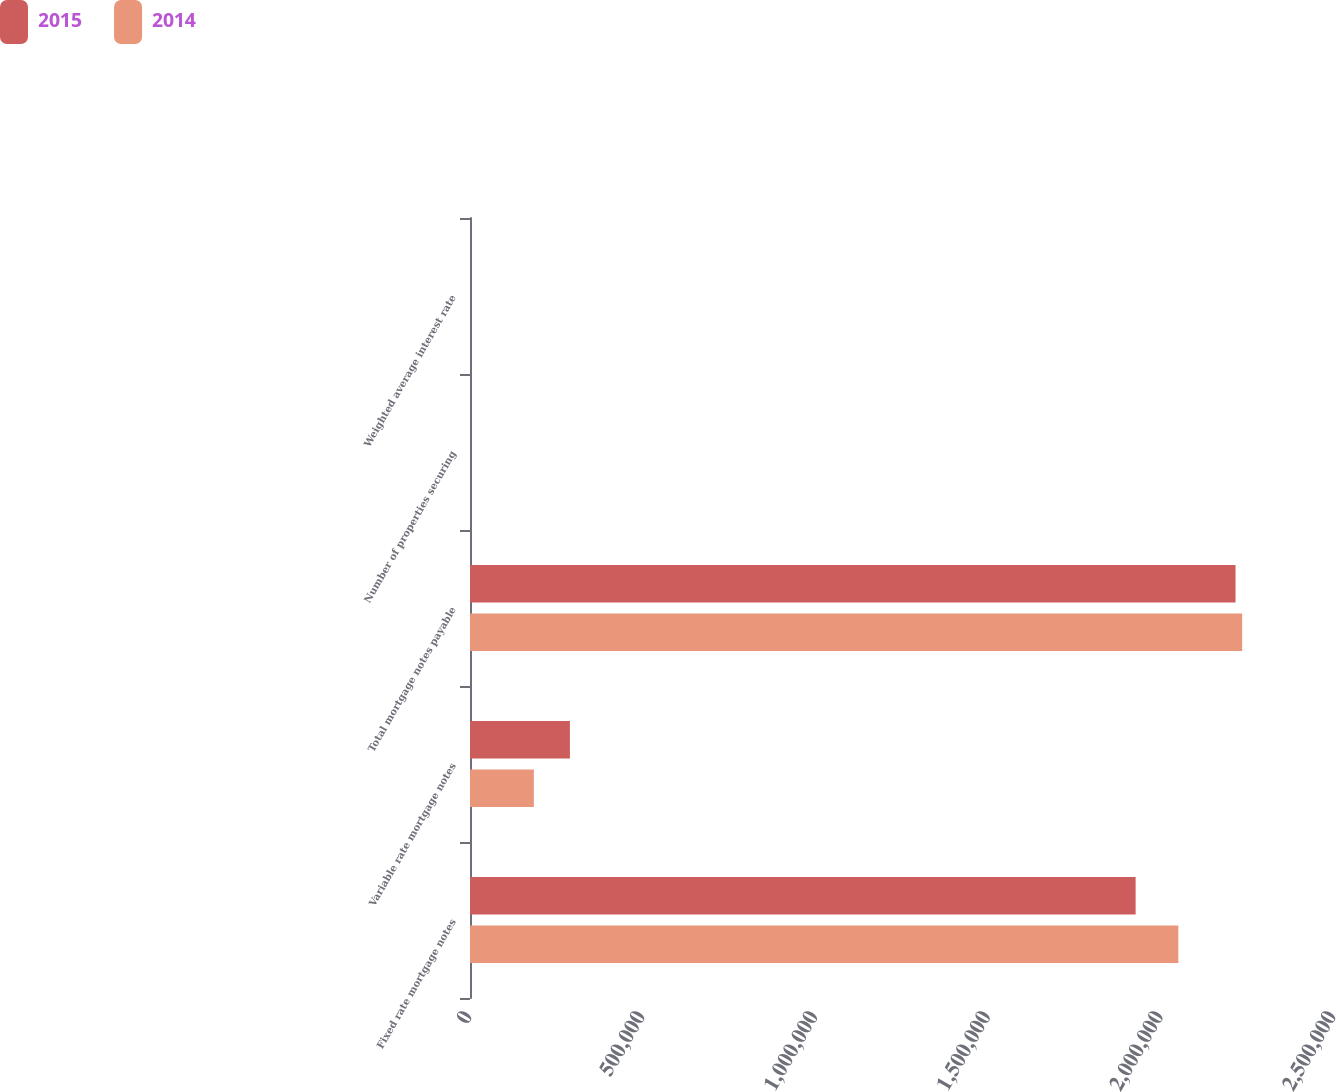<chart> <loc_0><loc_0><loc_500><loc_500><stacked_bar_chart><ecel><fcel>Fixed rate mortgage notes<fcel>Variable rate mortgage notes<fcel>Total mortgage notes payable<fcel>Number of properties securing<fcel>Weighted average interest rate<nl><fcel>2015<fcel>1.92598e+06<fcel>289092<fcel>2.21508e+06<fcel>64<fcel>4.4<nl><fcel>2014<fcel>2.04958e+06<fcel>184740<fcel>2.23432e+06<fcel>67<fcel>4.6<nl></chart> 